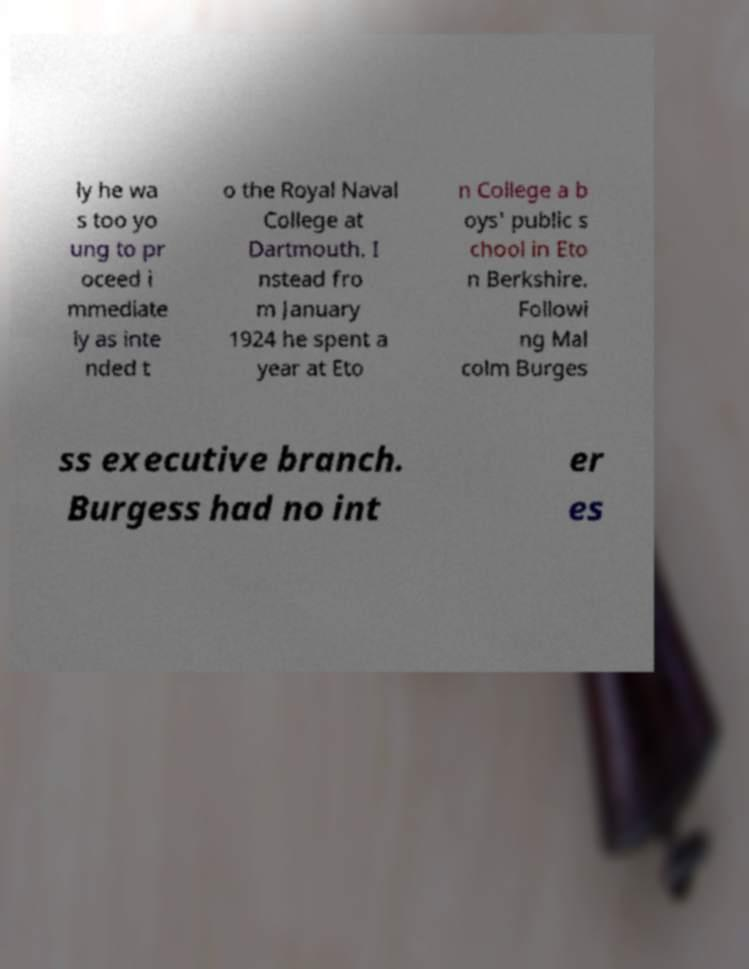Can you read and provide the text displayed in the image?This photo seems to have some interesting text. Can you extract and type it out for me? ly he wa s too yo ung to pr oceed i mmediate ly as inte nded t o the Royal Naval College at Dartmouth. I nstead fro m January 1924 he spent a year at Eto n College a b oys' public s chool in Eto n Berkshire. Followi ng Mal colm Burges ss executive branch. Burgess had no int er es 